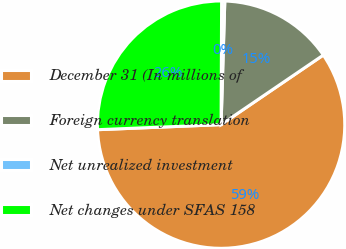Convert chart. <chart><loc_0><loc_0><loc_500><loc_500><pie_chart><fcel>December 31 (In millions of<fcel>Foreign currency translation<fcel>Net unrealized investment<fcel>Net changes under SFAS 158<nl><fcel>58.86%<fcel>15.01%<fcel>0.41%<fcel>25.72%<nl></chart> 